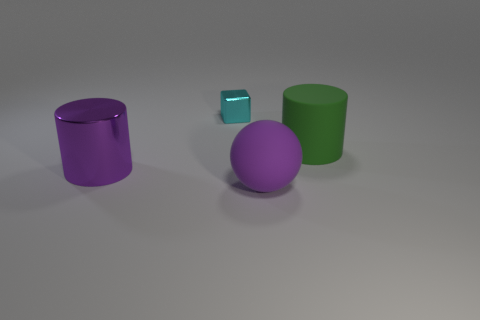How many other objects are there of the same color as the tiny object?
Offer a terse response. 0. There is a purple metallic thing that is the same size as the green object; what shape is it?
Your response must be concise. Cylinder. There is a metallic object that is behind the purple cylinder; how big is it?
Give a very brief answer. Small. There is a big shiny object on the left side of the big purple rubber object; is it the same color as the large rubber thing that is in front of the green object?
Ensure brevity in your answer.  Yes. There is a cylinder that is behind the big purple object behind the purple thing that is to the right of the small shiny cube; what is it made of?
Give a very brief answer. Rubber. Is there a brown rubber cylinder that has the same size as the shiny cylinder?
Your answer should be very brief. No. What is the material of the green cylinder that is the same size as the purple rubber object?
Provide a succinct answer. Rubber. The cyan metal object that is behind the purple rubber ball has what shape?
Ensure brevity in your answer.  Cube. Are the cylinder left of the green matte cylinder and the large cylinder that is on the right side of the tiny cyan metal thing made of the same material?
Provide a succinct answer. No. What number of other large objects have the same shape as the large purple metallic thing?
Your answer should be very brief. 1. 